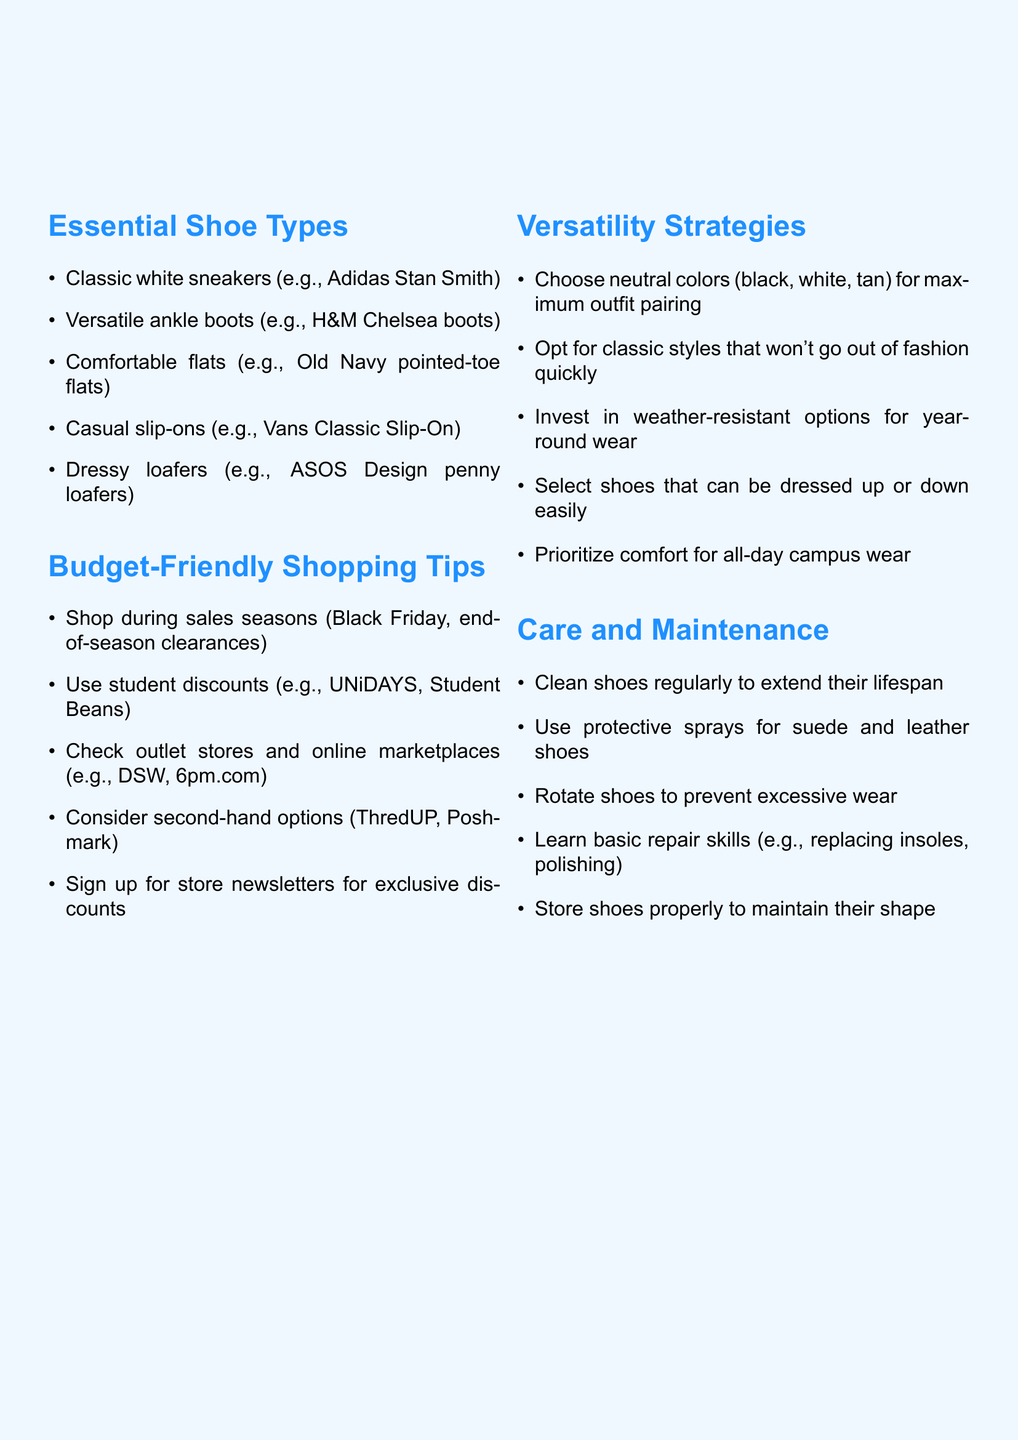What are the five essential shoe types? The document lists five essential shoe types, which are Classic white sneakers, Versatile ankle boots, Comfortable flats, Casual slip-ons, and Dressy loafers.
Answer: Classic white sneakers, Versatile ankle boots, Comfortable flats, Casual slip-ons, Dressy loafers Which student discount platforms are mentioned? The document mentions specific platforms where students can avail discounts, including UNiDAYS and Student Beans.
Answer: UNiDAYS, Student Beans What is a key strategy for maximizing outfit pairing with shoes? The document advises choosing neutral colors for shoes to maximize outfit pairing options.
Answer: Choose neutral colors How often should shoes be cleaned according to the care advice? The document states that shoes should be cleaned regularly to extend their lifespan, but does not specify an exact frequency.
Answer: Regularly Which style of shoes is recommended for weather resistance? The document suggests investing in weather-resistant options for year-round wear among the versatility strategies listed.
Answer: Weather-resistant options What type of shoe is recommended for casual wear according to the document? The document mentions Casual slip-ons as a versatile option for casual wear.
Answer: Casual slip-ons How can students benefit from signing up for store newsletters? The document states that signing up for store newsletters provides exclusive discounts, which benefits students shopping on a budget.
Answer: Exclusive discounts What is one basic repair skill that can help maintain shoes? The document lists basic repair skills, and one mentioned is replacing insoles, which can help in maintaining shoes.
Answer: Replacing insoles 